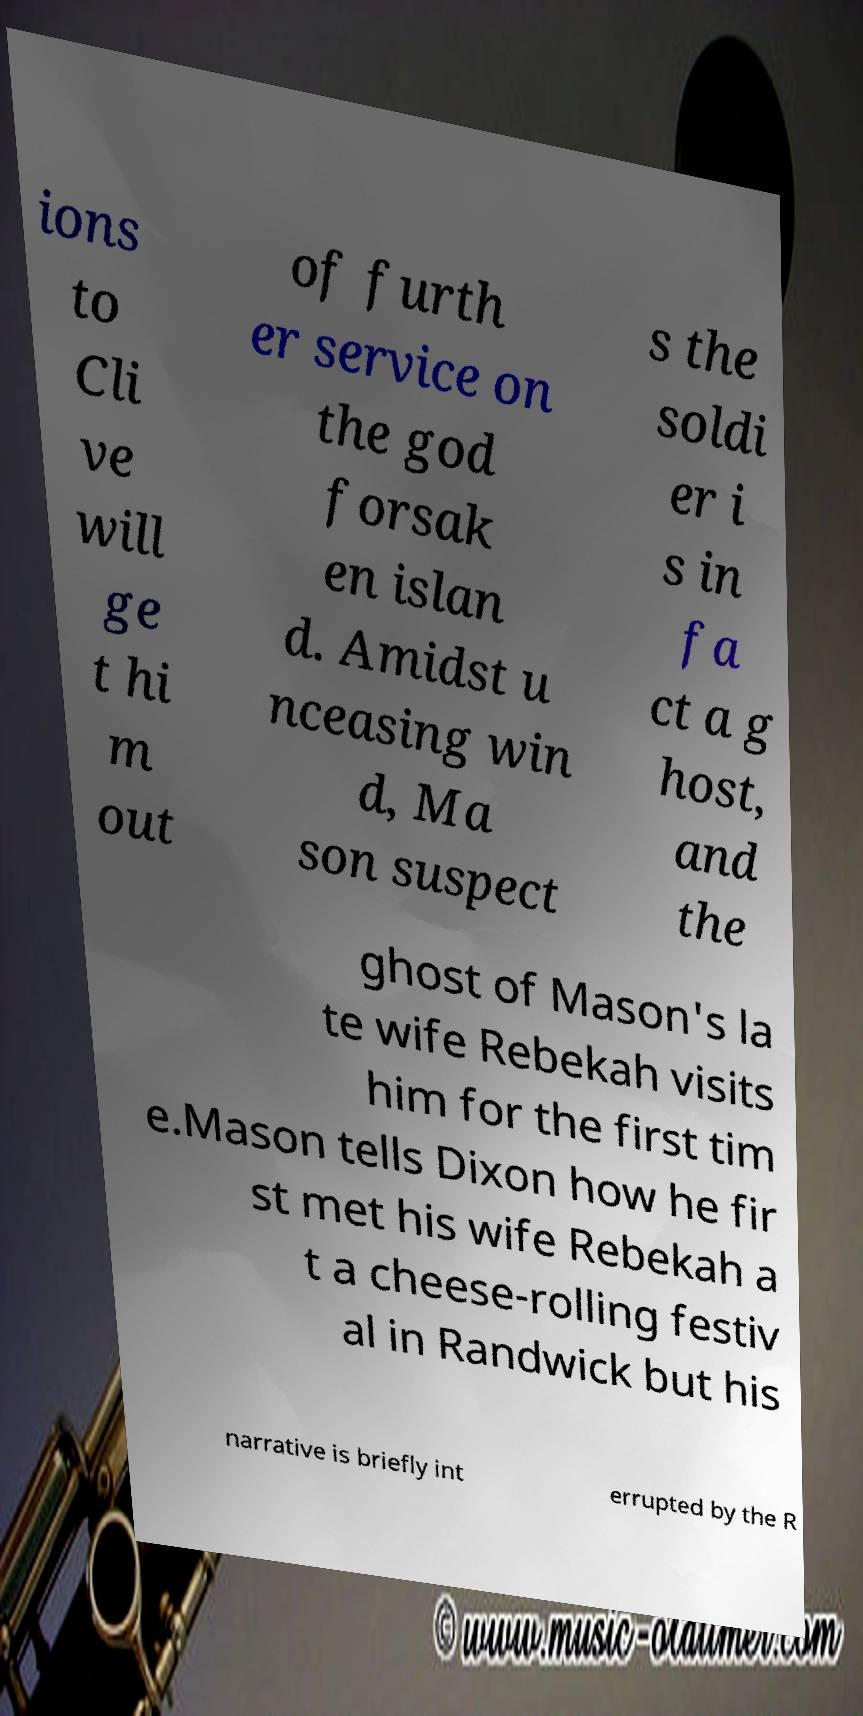Could you assist in decoding the text presented in this image and type it out clearly? ions to Cli ve will ge t hi m out of furth er service on the god forsak en islan d. Amidst u nceasing win d, Ma son suspect s the soldi er i s in fa ct a g host, and the ghost of Mason's la te wife Rebekah visits him for the first tim e.Mason tells Dixon how he fir st met his wife Rebekah a t a cheese-rolling festiv al in Randwick but his narrative is briefly int errupted by the R 